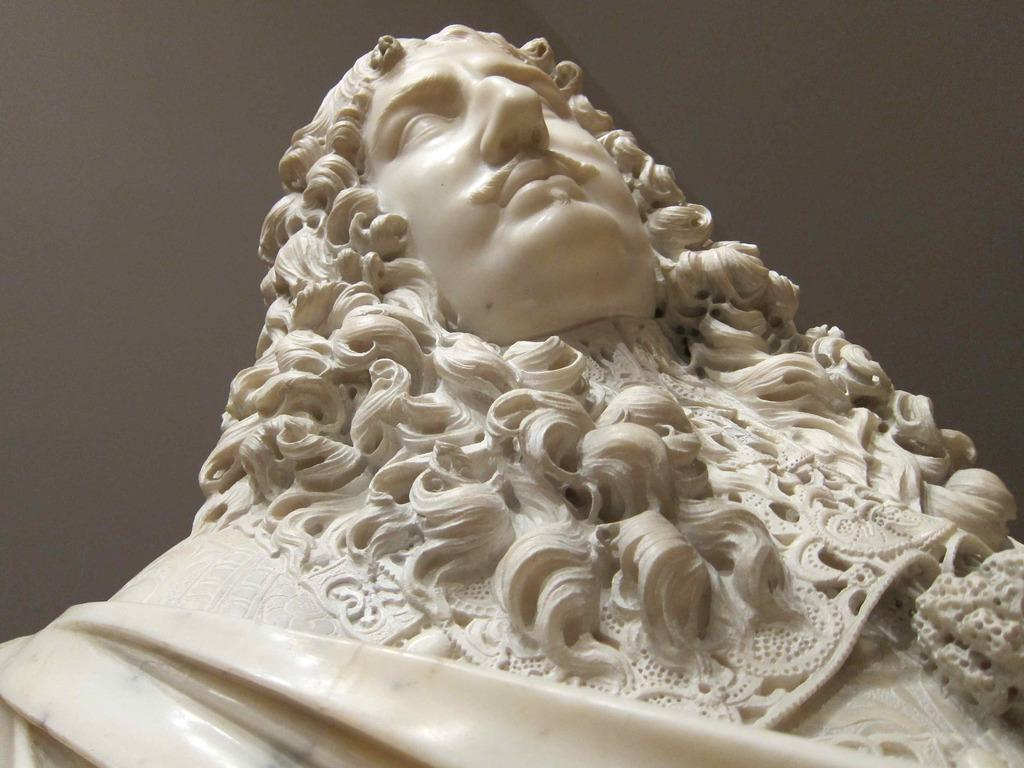What is the main subject in the image? There is a statue in the image. Can you describe the statue's surroundings? There is a wall visible behind the statue. What does the statue feel about the events of the night? The statue is an inanimate object and cannot feel regret or any emotions. 